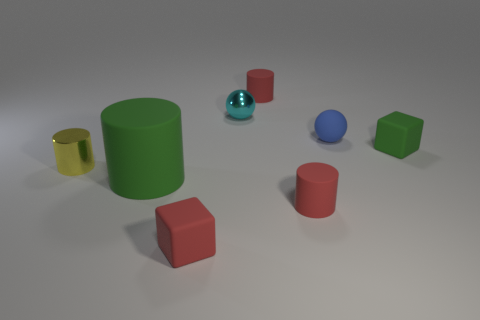Subtract all small cylinders. How many cylinders are left? 1 Add 1 tiny objects. How many objects exist? 9 Subtract 1 balls. How many balls are left? 1 Subtract all green blocks. How many blocks are left? 1 Subtract all cubes. How many objects are left? 6 Subtract all red spheres. Subtract all yellow cylinders. How many spheres are left? 2 Subtract all blue blocks. How many blue cylinders are left? 0 Subtract all tiny yellow cubes. Subtract all green blocks. How many objects are left? 7 Add 5 blue objects. How many blue objects are left? 6 Add 5 cyan shiny balls. How many cyan shiny balls exist? 6 